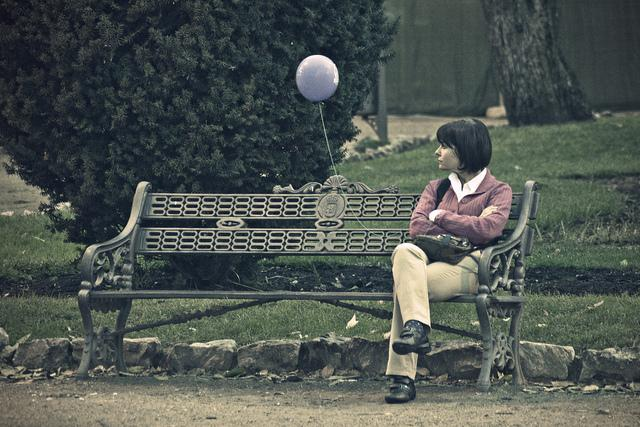What could pop that's attached to the bench? Please explain your reasoning. balloon. That's the only thing that could pop. 